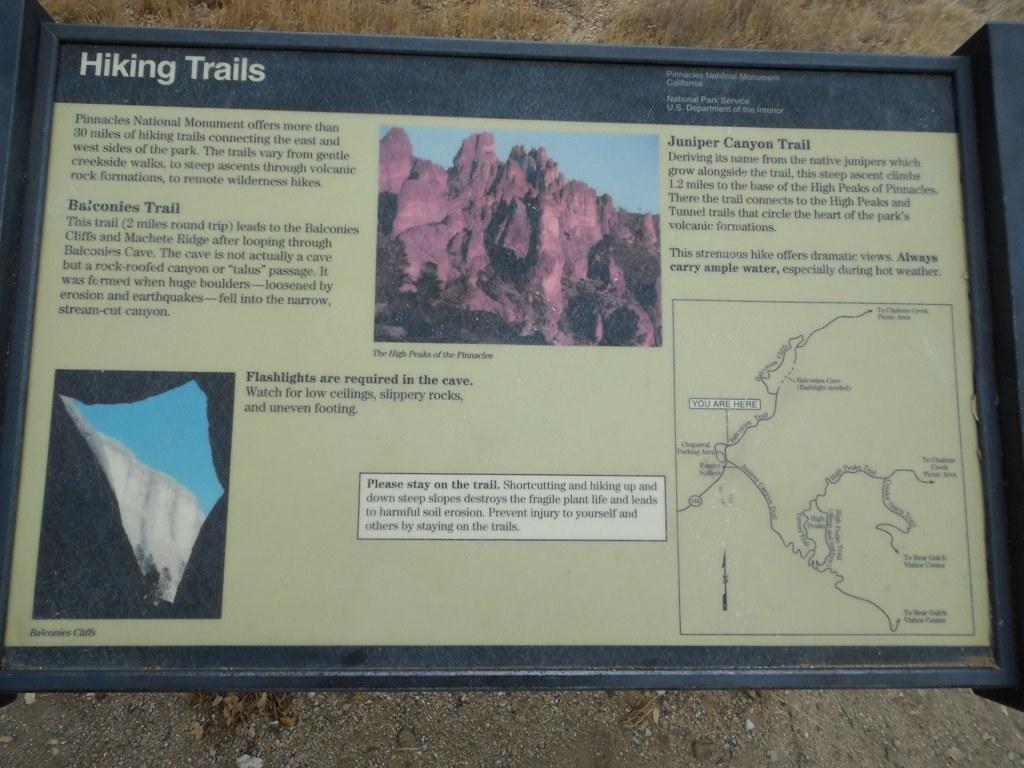What type of trails are this sign showing?
Keep it short and to the point. Hiking. What trail has a map on the right side of the sign?
Your answer should be very brief. Juniper canyon trail. 